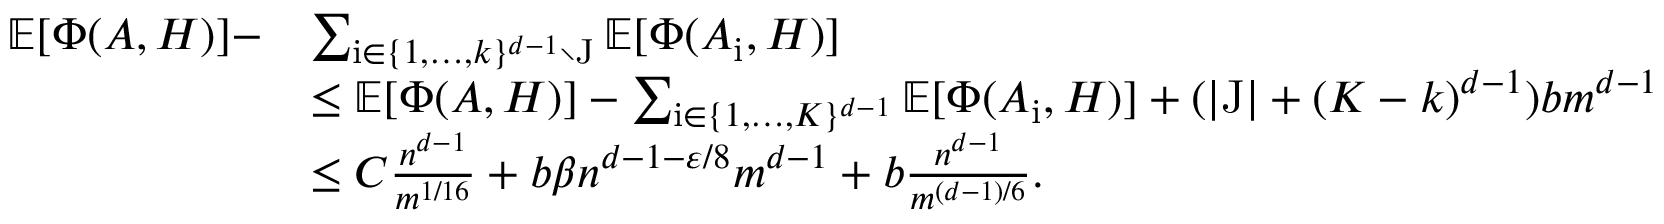Convert formula to latex. <formula><loc_0><loc_0><loc_500><loc_500>\begin{array} { r l } { \mathbb { E } [ \Phi ( A , H ) ] - } & { \sum _ { \mathrm i \in \{ 1 , \dots , k \} ^ { d - 1 } \ \mathrm J } \mathbb { E } [ \Phi ( A _ { \mathrm i } , H ) ] } \\ & { \leq \mathbb { E } [ \Phi ( A , H ) ] - \sum _ { \mathrm i \in \{ 1 , \dots , K \} ^ { d - 1 } } \mathbb { E } [ \Phi ( A _ { \mathrm i } , H ) ] + ( | \mathrm J | + ( K - k ) ^ { d - 1 } ) b m ^ { d - 1 } } \\ & { \leq C \frac { n ^ { d - 1 } } { m ^ { 1 / 1 6 } } + b \beta n ^ { d - 1 - \varepsilon / 8 } m ^ { d - 1 } + b \frac { n ^ { d - 1 } } { m ^ { ( d - 1 ) / 6 } } . } \end{array}</formula> 